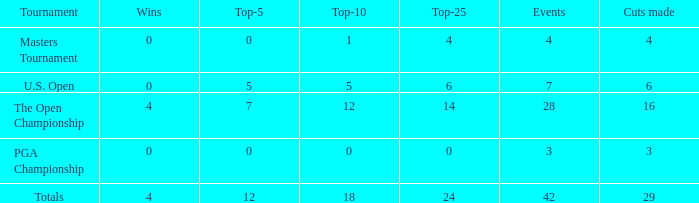What is the lowest for top-25 with events smaller than 42 in a U.S. Open with a top-10 smaller than 5? None. Help me parse the entirety of this table. {'header': ['Tournament', 'Wins', 'Top-5', 'Top-10', 'Top-25', 'Events', 'Cuts made'], 'rows': [['Masters Tournament', '0', '0', '1', '4', '4', '4'], ['U.S. Open', '0', '5', '5', '6', '7', '6'], ['The Open Championship', '4', '7', '12', '14', '28', '16'], ['PGA Championship', '0', '0', '0', '0', '3', '3'], ['Totals', '4', '12', '18', '24', '42', '29']]} 